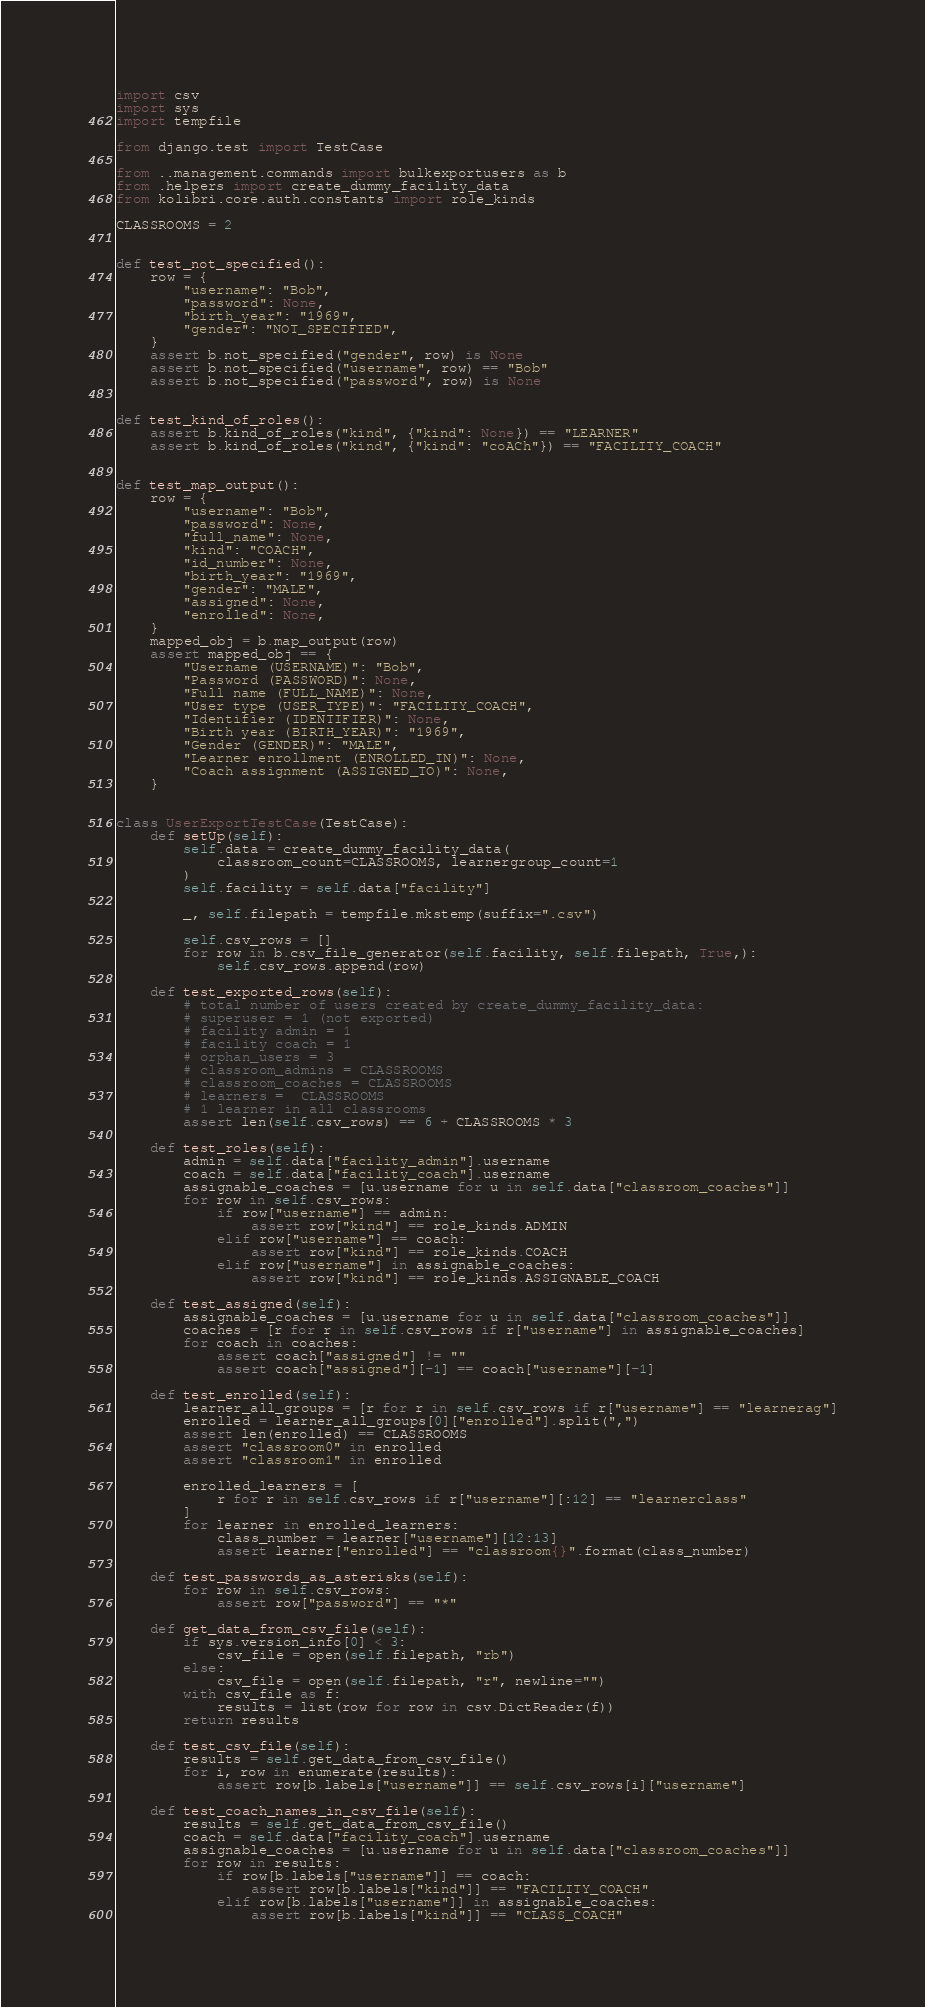Convert code to text. <code><loc_0><loc_0><loc_500><loc_500><_Python_>import csv
import sys
import tempfile

from django.test import TestCase

from ..management.commands import bulkexportusers as b
from .helpers import create_dummy_facility_data
from kolibri.core.auth.constants import role_kinds

CLASSROOMS = 2


def test_not_specified():
    row = {
        "username": "Bob",
        "password": None,
        "birth_year": "1969",
        "gender": "NOT_SPECIFIED",
    }
    assert b.not_specified("gender", row) is None
    assert b.not_specified("username", row) == "Bob"
    assert b.not_specified("password", row) is None


def test_kind_of_roles():
    assert b.kind_of_roles("kind", {"kind": None}) == "LEARNER"
    assert b.kind_of_roles("kind", {"kind": "coACh"}) == "FACILITY_COACH"


def test_map_output():
    row = {
        "username": "Bob",
        "password": None,
        "full_name": None,
        "kind": "COACH",
        "id_number": None,
        "birth_year": "1969",
        "gender": "MALE",
        "assigned": None,
        "enrolled": None,
    }
    mapped_obj = b.map_output(row)
    assert mapped_obj == {
        "Username (USERNAME)": "Bob",
        "Password (PASSWORD)": None,
        "Full name (FULL_NAME)": None,
        "User type (USER_TYPE)": "FACILITY_COACH",
        "Identifier (IDENTIFIER)": None,
        "Birth year (BIRTH_YEAR)": "1969",
        "Gender (GENDER)": "MALE",
        "Learner enrollment (ENROLLED_IN)": None,
        "Coach assignment (ASSIGNED_TO)": None,
    }


class UserExportTestCase(TestCase):
    def setUp(self):
        self.data = create_dummy_facility_data(
            classroom_count=CLASSROOMS, learnergroup_count=1
        )
        self.facility = self.data["facility"]

        _, self.filepath = tempfile.mkstemp(suffix=".csv")

        self.csv_rows = []
        for row in b.csv_file_generator(self.facility, self.filepath, True,):
            self.csv_rows.append(row)

    def test_exported_rows(self):
        # total number of users created by create_dummy_facility_data:
        # superuser = 1 (not exported)
        # facility admin = 1
        # facility coach = 1
        # orphan_users = 3
        # classroom_admins = CLASSROOMS
        # classroom_coaches = CLASSROOMS
        # learners =  CLASSROOMS
        # 1 learner in all classrooms
        assert len(self.csv_rows) == 6 + CLASSROOMS * 3

    def test_roles(self):
        admin = self.data["facility_admin"].username
        coach = self.data["facility_coach"].username
        assignable_coaches = [u.username for u in self.data["classroom_coaches"]]
        for row in self.csv_rows:
            if row["username"] == admin:
                assert row["kind"] == role_kinds.ADMIN
            elif row["username"] == coach:
                assert row["kind"] == role_kinds.COACH
            elif row["username"] in assignable_coaches:
                assert row["kind"] == role_kinds.ASSIGNABLE_COACH

    def test_assigned(self):
        assignable_coaches = [u.username for u in self.data["classroom_coaches"]]
        coaches = [r for r in self.csv_rows if r["username"] in assignable_coaches]
        for coach in coaches:
            assert coach["assigned"] != ""
            assert coach["assigned"][-1] == coach["username"][-1]

    def test_enrolled(self):
        learner_all_groups = [r for r in self.csv_rows if r["username"] == "learnerag"]
        enrolled = learner_all_groups[0]["enrolled"].split(",")
        assert len(enrolled) == CLASSROOMS
        assert "classroom0" in enrolled
        assert "classroom1" in enrolled

        enrolled_learners = [
            r for r in self.csv_rows if r["username"][:12] == "learnerclass"
        ]
        for learner in enrolled_learners:
            class_number = learner["username"][12:13]
            assert learner["enrolled"] == "classroom{}".format(class_number)

    def test_passwords_as_asterisks(self):
        for row in self.csv_rows:
            assert row["password"] == "*"

    def get_data_from_csv_file(self):
        if sys.version_info[0] < 3:
            csv_file = open(self.filepath, "rb")
        else:
            csv_file = open(self.filepath, "r", newline="")
        with csv_file as f:
            results = list(row for row in csv.DictReader(f))
        return results

    def test_csv_file(self):
        results = self.get_data_from_csv_file()
        for i, row in enumerate(results):
            assert row[b.labels["username"]] == self.csv_rows[i]["username"]

    def test_coach_names_in_csv_file(self):
        results = self.get_data_from_csv_file()
        coach = self.data["facility_coach"].username
        assignable_coaches = [u.username for u in self.data["classroom_coaches"]]
        for row in results:
            if row[b.labels["username"]] == coach:
                assert row[b.labels["kind"]] == "FACILITY_COACH"
            elif row[b.labels["username"]] in assignable_coaches:
                assert row[b.labels["kind"]] == "CLASS_COACH"
</code> 